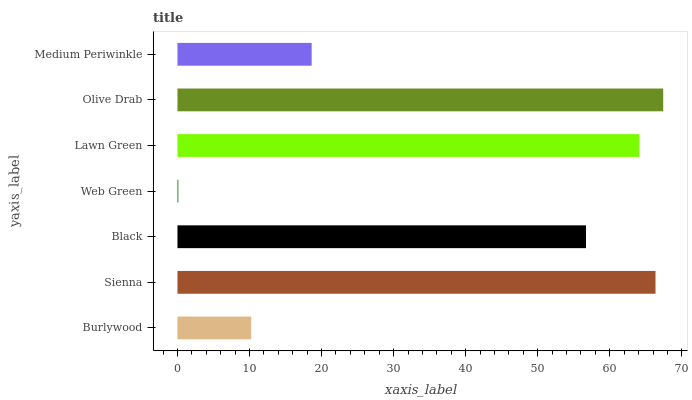Is Web Green the minimum?
Answer yes or no. Yes. Is Olive Drab the maximum?
Answer yes or no. Yes. Is Sienna the minimum?
Answer yes or no. No. Is Sienna the maximum?
Answer yes or no. No. Is Sienna greater than Burlywood?
Answer yes or no. Yes. Is Burlywood less than Sienna?
Answer yes or no. Yes. Is Burlywood greater than Sienna?
Answer yes or no. No. Is Sienna less than Burlywood?
Answer yes or no. No. Is Black the high median?
Answer yes or no. Yes. Is Black the low median?
Answer yes or no. Yes. Is Olive Drab the high median?
Answer yes or no. No. Is Sienna the low median?
Answer yes or no. No. 